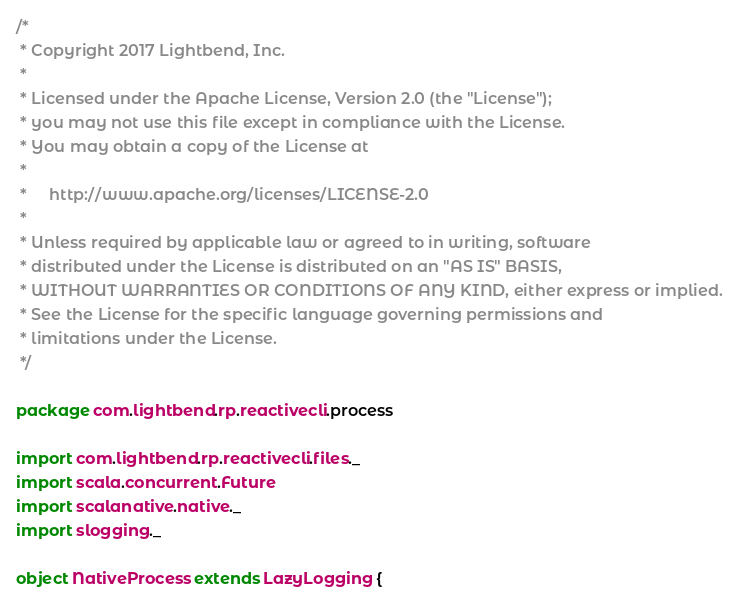Convert code to text. <code><loc_0><loc_0><loc_500><loc_500><_Scala_>/*
 * Copyright 2017 Lightbend, Inc.
 *
 * Licensed under the Apache License, Version 2.0 (the "License");
 * you may not use this file except in compliance with the License.
 * You may obtain a copy of the License at
 *
 *     http://www.apache.org/licenses/LICENSE-2.0
 *
 * Unless required by applicable law or agreed to in writing, software
 * distributed under the License is distributed on an "AS IS" BASIS,
 * WITHOUT WARRANTIES OR CONDITIONS OF ANY KIND, either express or implied.
 * See the License for the specific language governing permissions and
 * limitations under the License.
 */

package com.lightbend.rp.reactivecli.process

import com.lightbend.rp.reactivecli.files._
import scala.concurrent.Future
import scalanative.native._
import slogging._

object NativeProcess extends LazyLogging {</code> 